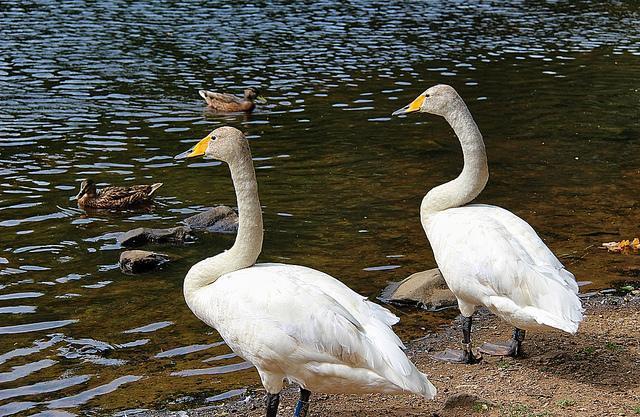How many birds are there?
Give a very brief answer. 2. 